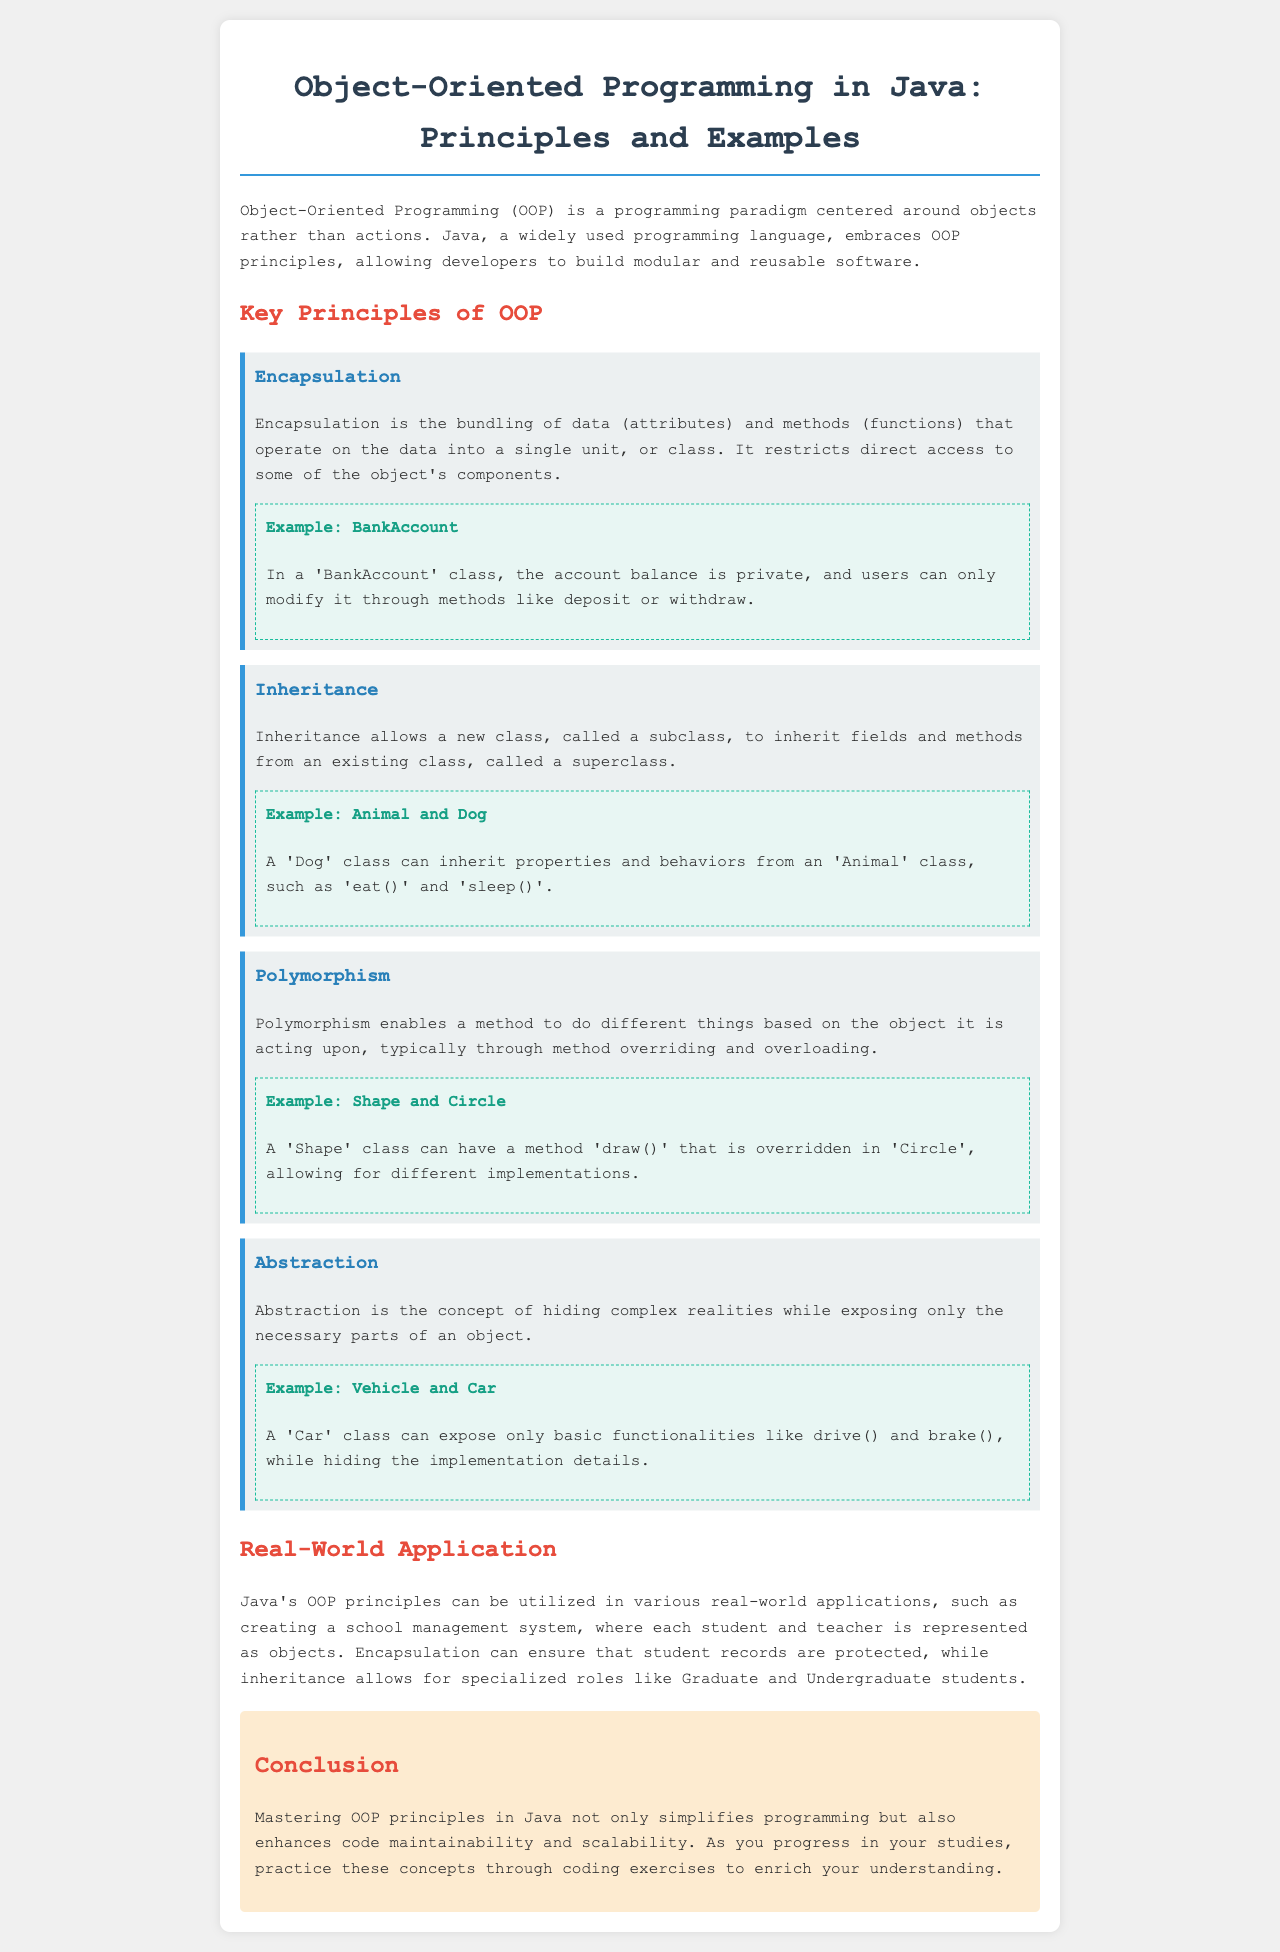What is the title of the document? The title of the document is presented in the header section, prominently displayed.
Answer: Object-Oriented Programming in Java: Principles and Examples What is the first principle of OOP mentioned? The first principle listed in the document is mentioned in the section on key principles.
Answer: Encapsulation Which example is provided for Inheritance? The example provided for Inheritance explains how classes relate to each other, specifically mentioned within its respective section.
Answer: Animal and Dog What color is used for the headings in the principle sections? The color used for the headings in the principle sections is indicated in the styling of the document.
Answer: #2980b9 How many key principles of OOP are discussed? The number of key principles is gathered from counting the sections under the key principles heading.
Answer: Four What type of system is mentioned as a real-world application of OOP in Java? The type of system serves as an illustrative example within the document.
Answer: School management system What is the background color of the conclusion section? The background color is defined in the styling of the conclusion section in the document.
Answer: #fdebd0 What is the main benefit of mastering OOP principles in Java as stated in the conclusion? The benefit mentioned in the conclusion is a summary of the advantages of applying what is learned.
Answer: Enhances code maintainability and scalability What method is overridden in the example of Polymorphism? The document specifies which method is involved in the example of Polymorphism.
Answer: draw() 